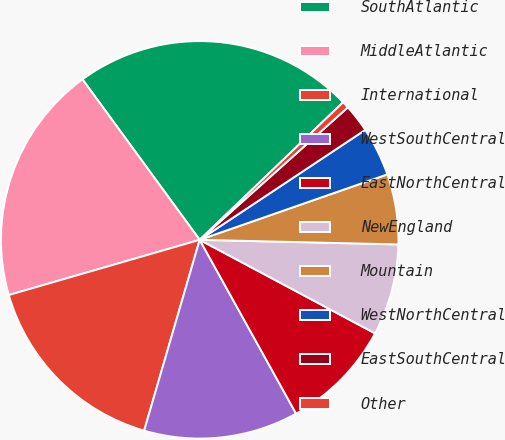Convert chart to OTSL. <chart><loc_0><loc_0><loc_500><loc_500><pie_chart><fcel>SouthAtlantic<fcel>MiddleAtlantic<fcel>International<fcel>WestSouthCentral<fcel>EastNorthCentral<fcel>NewEngland<fcel>Mountain<fcel>WestNorthCentral<fcel>EastSouthCentral<fcel>Other<nl><fcel>22.87%<fcel>19.44%<fcel>16.01%<fcel>12.57%<fcel>9.14%<fcel>7.43%<fcel>5.71%<fcel>3.99%<fcel>2.28%<fcel>0.56%<nl></chart> 